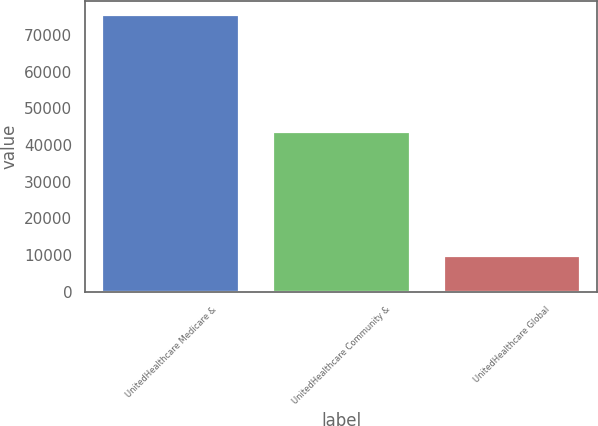<chart> <loc_0><loc_0><loc_500><loc_500><bar_chart><fcel>UnitedHealthcare Medicare &<fcel>UnitedHealthcare Community &<fcel>UnitedHealthcare Global<nl><fcel>75473<fcel>43426<fcel>9816<nl></chart> 